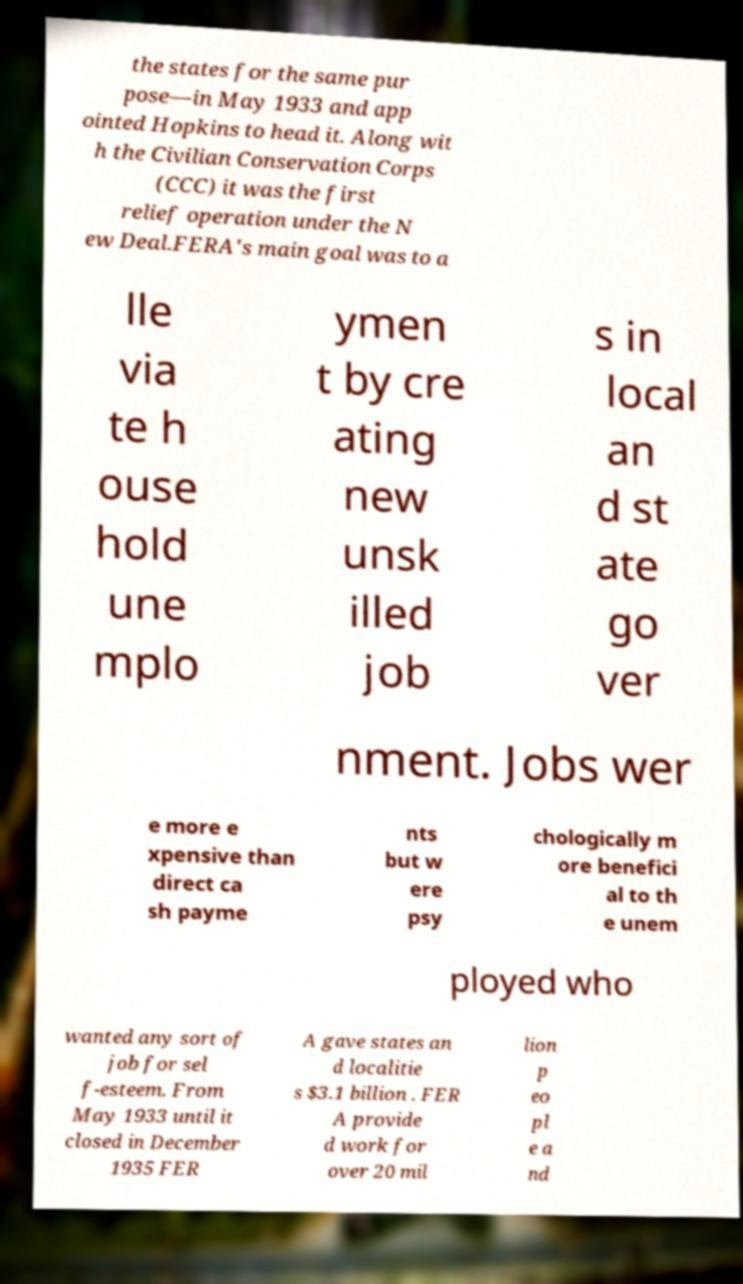For documentation purposes, I need the text within this image transcribed. Could you provide that? the states for the same pur pose—in May 1933 and app ointed Hopkins to head it. Along wit h the Civilian Conservation Corps (CCC) it was the first relief operation under the N ew Deal.FERA's main goal was to a lle via te h ouse hold une mplo ymen t by cre ating new unsk illed job s in local an d st ate go ver nment. Jobs wer e more e xpensive than direct ca sh payme nts but w ere psy chologically m ore benefici al to th e unem ployed who wanted any sort of job for sel f-esteem. From May 1933 until it closed in December 1935 FER A gave states an d localitie s $3.1 billion . FER A provide d work for over 20 mil lion p eo pl e a nd 